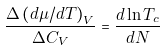<formula> <loc_0><loc_0><loc_500><loc_500>\frac { \Delta \left ( d \mu / d T \right ) _ { V } } { \Delta C _ { V } } = \frac { d \ln T _ { c } } { d N }</formula> 